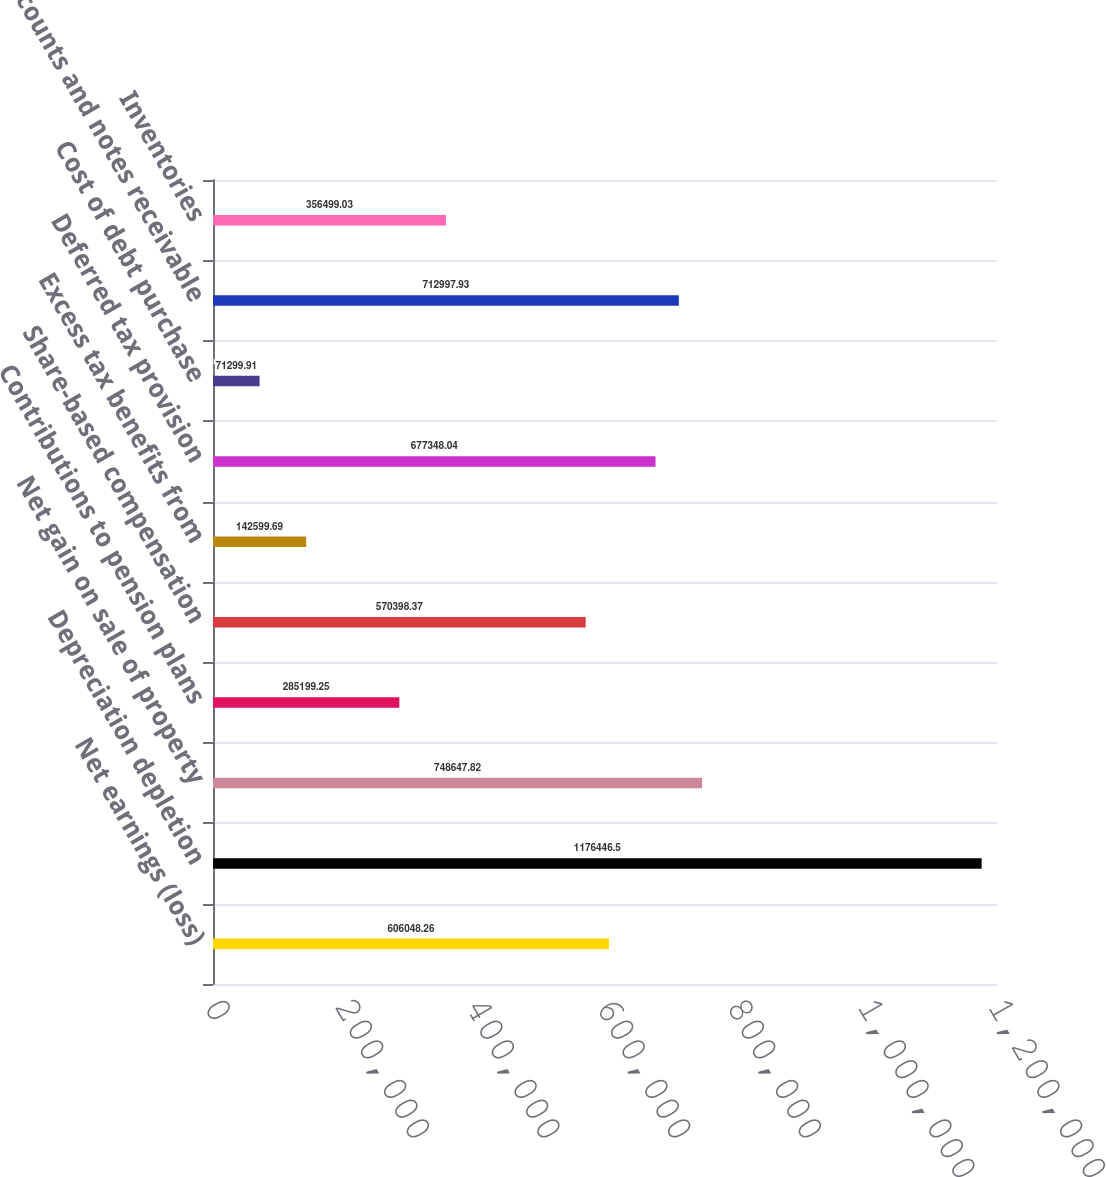Convert chart to OTSL. <chart><loc_0><loc_0><loc_500><loc_500><bar_chart><fcel>Net earnings (loss)<fcel>Depreciation depletion<fcel>Net gain on sale of property<fcel>Contributions to pension plans<fcel>Share-based compensation<fcel>Excess tax benefits from<fcel>Deferred tax provision<fcel>Cost of debt purchase<fcel>Accounts and notes receivable<fcel>Inventories<nl><fcel>606048<fcel>1.17645e+06<fcel>748648<fcel>285199<fcel>570398<fcel>142600<fcel>677348<fcel>71299.9<fcel>712998<fcel>356499<nl></chart> 